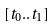<formula> <loc_0><loc_0><loc_500><loc_500>[ t _ { 0 } . . t _ { 1 } ]</formula> 